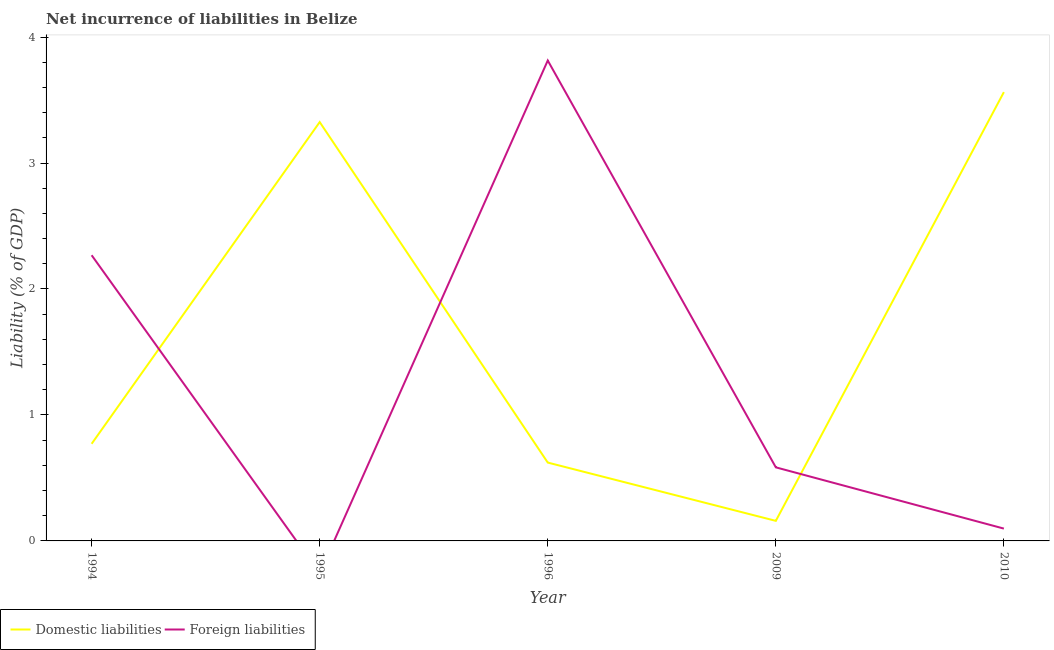How many different coloured lines are there?
Make the answer very short. 2. Does the line corresponding to incurrence of foreign liabilities intersect with the line corresponding to incurrence of domestic liabilities?
Give a very brief answer. Yes. What is the incurrence of foreign liabilities in 2010?
Offer a terse response. 0.1. Across all years, what is the maximum incurrence of domestic liabilities?
Offer a terse response. 3.56. Across all years, what is the minimum incurrence of foreign liabilities?
Your response must be concise. 0. In which year was the incurrence of domestic liabilities maximum?
Make the answer very short. 2010. What is the total incurrence of foreign liabilities in the graph?
Make the answer very short. 6.76. What is the difference between the incurrence of domestic liabilities in 1995 and that in 2009?
Ensure brevity in your answer.  3.17. What is the difference between the incurrence of foreign liabilities in 1994 and the incurrence of domestic liabilities in 1995?
Make the answer very short. -1.06. What is the average incurrence of domestic liabilities per year?
Provide a succinct answer. 1.69. In the year 2009, what is the difference between the incurrence of domestic liabilities and incurrence of foreign liabilities?
Provide a succinct answer. -0.42. In how many years, is the incurrence of domestic liabilities greater than 1.8 %?
Offer a very short reply. 2. What is the ratio of the incurrence of domestic liabilities in 1996 to that in 2009?
Provide a succinct answer. 3.91. Is the incurrence of domestic liabilities in 1994 less than that in 1995?
Make the answer very short. Yes. What is the difference between the highest and the second highest incurrence of domestic liabilities?
Your response must be concise. 0.24. What is the difference between the highest and the lowest incurrence of domestic liabilities?
Your answer should be very brief. 3.4. In how many years, is the incurrence of foreign liabilities greater than the average incurrence of foreign liabilities taken over all years?
Make the answer very short. 2. Is the sum of the incurrence of domestic liabilities in 1994 and 1996 greater than the maximum incurrence of foreign liabilities across all years?
Give a very brief answer. No. Is the incurrence of foreign liabilities strictly greater than the incurrence of domestic liabilities over the years?
Provide a succinct answer. No. How many years are there in the graph?
Give a very brief answer. 5. Does the graph contain grids?
Offer a very short reply. No. Where does the legend appear in the graph?
Give a very brief answer. Bottom left. What is the title of the graph?
Keep it short and to the point. Net incurrence of liabilities in Belize. What is the label or title of the Y-axis?
Give a very brief answer. Liability (% of GDP). What is the Liability (% of GDP) of Domestic liabilities in 1994?
Offer a terse response. 0.77. What is the Liability (% of GDP) of Foreign liabilities in 1994?
Provide a short and direct response. 2.27. What is the Liability (% of GDP) in Domestic liabilities in 1995?
Ensure brevity in your answer.  3.32. What is the Liability (% of GDP) of Foreign liabilities in 1995?
Offer a terse response. 0. What is the Liability (% of GDP) of Domestic liabilities in 1996?
Your response must be concise. 0.62. What is the Liability (% of GDP) of Foreign liabilities in 1996?
Your answer should be very brief. 3.81. What is the Liability (% of GDP) of Domestic liabilities in 2009?
Ensure brevity in your answer.  0.16. What is the Liability (% of GDP) of Foreign liabilities in 2009?
Provide a succinct answer. 0.58. What is the Liability (% of GDP) of Domestic liabilities in 2010?
Ensure brevity in your answer.  3.56. What is the Liability (% of GDP) in Foreign liabilities in 2010?
Provide a succinct answer. 0.1. Across all years, what is the maximum Liability (% of GDP) in Domestic liabilities?
Your answer should be very brief. 3.56. Across all years, what is the maximum Liability (% of GDP) of Foreign liabilities?
Your answer should be compact. 3.81. Across all years, what is the minimum Liability (% of GDP) of Domestic liabilities?
Provide a short and direct response. 0.16. What is the total Liability (% of GDP) of Domestic liabilities in the graph?
Provide a succinct answer. 8.44. What is the total Liability (% of GDP) in Foreign liabilities in the graph?
Ensure brevity in your answer.  6.76. What is the difference between the Liability (% of GDP) in Domestic liabilities in 1994 and that in 1995?
Offer a very short reply. -2.55. What is the difference between the Liability (% of GDP) in Domestic liabilities in 1994 and that in 1996?
Your answer should be compact. 0.15. What is the difference between the Liability (% of GDP) of Foreign liabilities in 1994 and that in 1996?
Your answer should be compact. -1.55. What is the difference between the Liability (% of GDP) of Domestic liabilities in 1994 and that in 2009?
Ensure brevity in your answer.  0.61. What is the difference between the Liability (% of GDP) in Foreign liabilities in 1994 and that in 2009?
Provide a succinct answer. 1.68. What is the difference between the Liability (% of GDP) in Domestic liabilities in 1994 and that in 2010?
Keep it short and to the point. -2.79. What is the difference between the Liability (% of GDP) in Foreign liabilities in 1994 and that in 2010?
Keep it short and to the point. 2.17. What is the difference between the Liability (% of GDP) in Domestic liabilities in 1995 and that in 1996?
Provide a short and direct response. 2.7. What is the difference between the Liability (% of GDP) in Domestic liabilities in 1995 and that in 2009?
Provide a succinct answer. 3.17. What is the difference between the Liability (% of GDP) of Domestic liabilities in 1995 and that in 2010?
Your answer should be very brief. -0.24. What is the difference between the Liability (% of GDP) of Domestic liabilities in 1996 and that in 2009?
Offer a very short reply. 0.46. What is the difference between the Liability (% of GDP) of Foreign liabilities in 1996 and that in 2009?
Give a very brief answer. 3.23. What is the difference between the Liability (% of GDP) in Domestic liabilities in 1996 and that in 2010?
Give a very brief answer. -2.94. What is the difference between the Liability (% of GDP) in Foreign liabilities in 1996 and that in 2010?
Provide a succinct answer. 3.72. What is the difference between the Liability (% of GDP) in Domestic liabilities in 2009 and that in 2010?
Provide a succinct answer. -3.4. What is the difference between the Liability (% of GDP) in Foreign liabilities in 2009 and that in 2010?
Your answer should be compact. 0.49. What is the difference between the Liability (% of GDP) in Domestic liabilities in 1994 and the Liability (% of GDP) in Foreign liabilities in 1996?
Offer a terse response. -3.04. What is the difference between the Liability (% of GDP) of Domestic liabilities in 1994 and the Liability (% of GDP) of Foreign liabilities in 2009?
Your response must be concise. 0.19. What is the difference between the Liability (% of GDP) of Domestic liabilities in 1994 and the Liability (% of GDP) of Foreign liabilities in 2010?
Make the answer very short. 0.67. What is the difference between the Liability (% of GDP) in Domestic liabilities in 1995 and the Liability (% of GDP) in Foreign liabilities in 1996?
Provide a succinct answer. -0.49. What is the difference between the Liability (% of GDP) of Domestic liabilities in 1995 and the Liability (% of GDP) of Foreign liabilities in 2009?
Make the answer very short. 2.74. What is the difference between the Liability (% of GDP) of Domestic liabilities in 1995 and the Liability (% of GDP) of Foreign liabilities in 2010?
Offer a terse response. 3.23. What is the difference between the Liability (% of GDP) of Domestic liabilities in 1996 and the Liability (% of GDP) of Foreign liabilities in 2009?
Ensure brevity in your answer.  0.04. What is the difference between the Liability (% of GDP) of Domestic liabilities in 1996 and the Liability (% of GDP) of Foreign liabilities in 2010?
Your answer should be very brief. 0.52. What is the difference between the Liability (% of GDP) of Domestic liabilities in 2009 and the Liability (% of GDP) of Foreign liabilities in 2010?
Keep it short and to the point. 0.06. What is the average Liability (% of GDP) in Domestic liabilities per year?
Keep it short and to the point. 1.69. What is the average Liability (% of GDP) of Foreign liabilities per year?
Your response must be concise. 1.35. In the year 1994, what is the difference between the Liability (% of GDP) in Domestic liabilities and Liability (% of GDP) in Foreign liabilities?
Offer a very short reply. -1.5. In the year 1996, what is the difference between the Liability (% of GDP) of Domestic liabilities and Liability (% of GDP) of Foreign liabilities?
Give a very brief answer. -3.19. In the year 2009, what is the difference between the Liability (% of GDP) in Domestic liabilities and Liability (% of GDP) in Foreign liabilities?
Give a very brief answer. -0.42. In the year 2010, what is the difference between the Liability (% of GDP) of Domestic liabilities and Liability (% of GDP) of Foreign liabilities?
Provide a succinct answer. 3.46. What is the ratio of the Liability (% of GDP) in Domestic liabilities in 1994 to that in 1995?
Your response must be concise. 0.23. What is the ratio of the Liability (% of GDP) in Domestic liabilities in 1994 to that in 1996?
Your answer should be very brief. 1.24. What is the ratio of the Liability (% of GDP) of Foreign liabilities in 1994 to that in 1996?
Make the answer very short. 0.59. What is the ratio of the Liability (% of GDP) of Domestic liabilities in 1994 to that in 2009?
Provide a short and direct response. 4.84. What is the ratio of the Liability (% of GDP) of Foreign liabilities in 1994 to that in 2009?
Provide a short and direct response. 3.88. What is the ratio of the Liability (% of GDP) in Domestic liabilities in 1994 to that in 2010?
Offer a very short reply. 0.22. What is the ratio of the Liability (% of GDP) of Foreign liabilities in 1994 to that in 2010?
Offer a very short reply. 23.17. What is the ratio of the Liability (% of GDP) of Domestic liabilities in 1995 to that in 1996?
Your answer should be very brief. 5.35. What is the ratio of the Liability (% of GDP) of Domestic liabilities in 1995 to that in 2009?
Keep it short and to the point. 20.88. What is the ratio of the Liability (% of GDP) of Domestic liabilities in 1995 to that in 2010?
Provide a short and direct response. 0.93. What is the ratio of the Liability (% of GDP) in Domestic liabilities in 1996 to that in 2009?
Provide a succinct answer. 3.91. What is the ratio of the Liability (% of GDP) in Foreign liabilities in 1996 to that in 2009?
Offer a terse response. 6.53. What is the ratio of the Liability (% of GDP) of Domestic liabilities in 1996 to that in 2010?
Your answer should be very brief. 0.17. What is the ratio of the Liability (% of GDP) of Foreign liabilities in 1996 to that in 2010?
Your response must be concise. 38.96. What is the ratio of the Liability (% of GDP) in Domestic liabilities in 2009 to that in 2010?
Provide a short and direct response. 0.04. What is the ratio of the Liability (% of GDP) in Foreign liabilities in 2009 to that in 2010?
Give a very brief answer. 5.97. What is the difference between the highest and the second highest Liability (% of GDP) in Domestic liabilities?
Make the answer very short. 0.24. What is the difference between the highest and the second highest Liability (% of GDP) in Foreign liabilities?
Provide a succinct answer. 1.55. What is the difference between the highest and the lowest Liability (% of GDP) in Domestic liabilities?
Offer a very short reply. 3.4. What is the difference between the highest and the lowest Liability (% of GDP) in Foreign liabilities?
Your response must be concise. 3.81. 